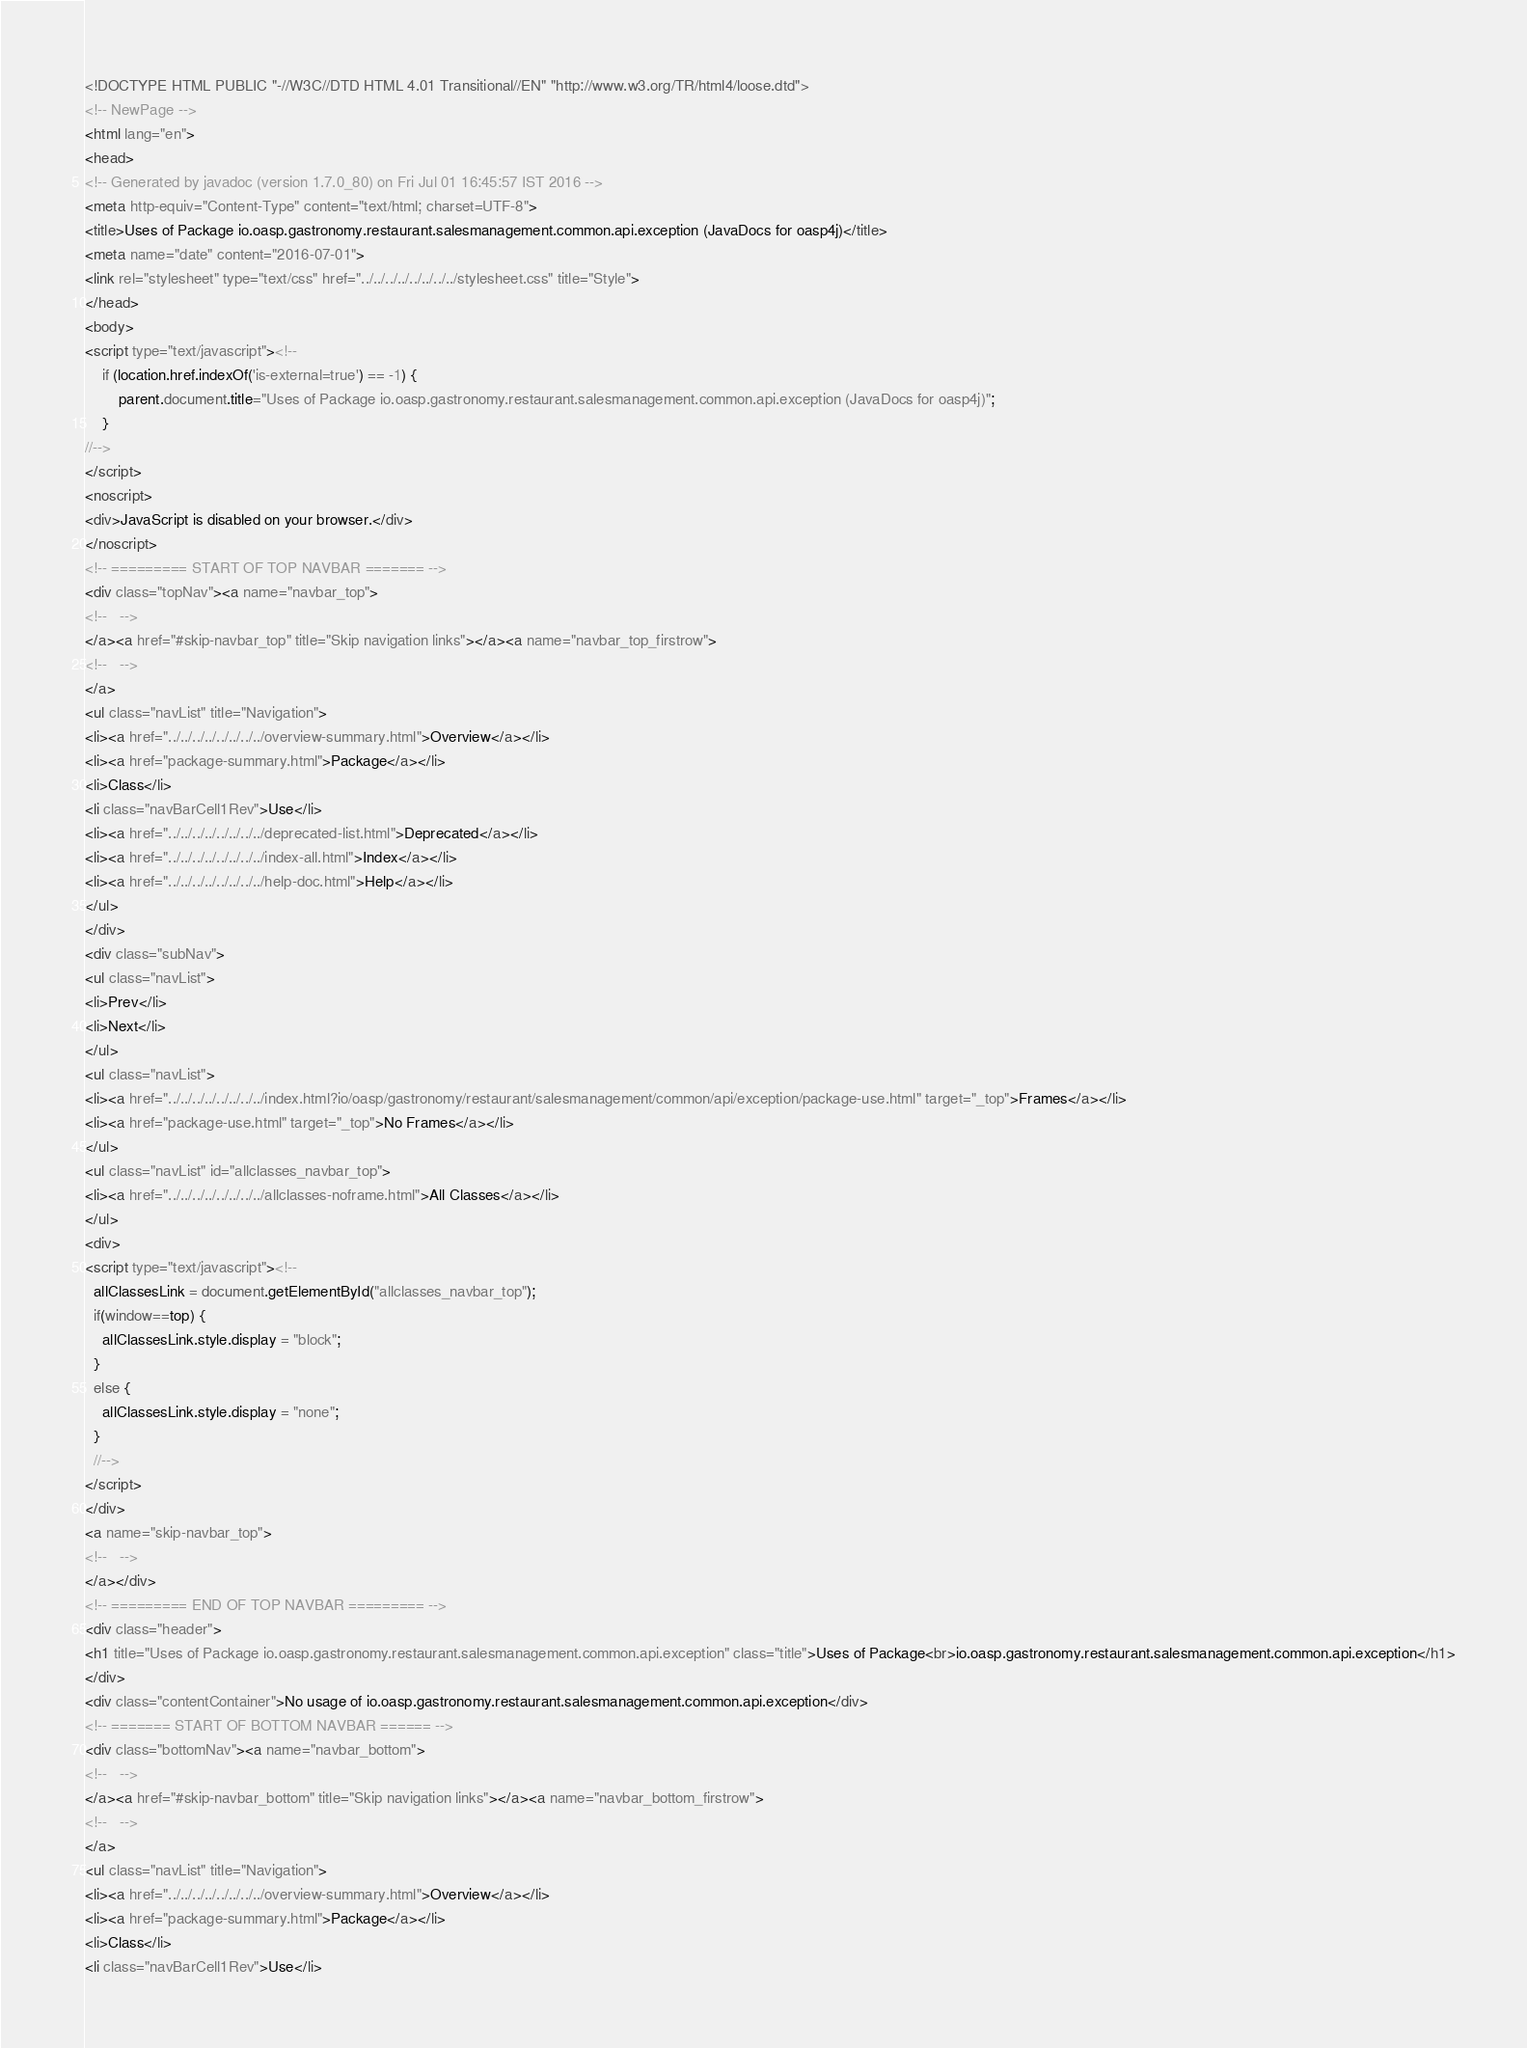Convert code to text. <code><loc_0><loc_0><loc_500><loc_500><_HTML_><!DOCTYPE HTML PUBLIC "-//W3C//DTD HTML 4.01 Transitional//EN" "http://www.w3.org/TR/html4/loose.dtd">
<!-- NewPage -->
<html lang="en">
<head>
<!-- Generated by javadoc (version 1.7.0_80) on Fri Jul 01 16:45:57 IST 2016 -->
<meta http-equiv="Content-Type" content="text/html; charset=UTF-8">
<title>Uses of Package io.oasp.gastronomy.restaurant.salesmanagement.common.api.exception (JavaDocs for oasp4j)</title>
<meta name="date" content="2016-07-01">
<link rel="stylesheet" type="text/css" href="../../../../../../../../stylesheet.css" title="Style">
</head>
<body>
<script type="text/javascript"><!--
    if (location.href.indexOf('is-external=true') == -1) {
        parent.document.title="Uses of Package io.oasp.gastronomy.restaurant.salesmanagement.common.api.exception (JavaDocs for oasp4j)";
    }
//-->
</script>
<noscript>
<div>JavaScript is disabled on your browser.</div>
</noscript>
<!-- ========= START OF TOP NAVBAR ======= -->
<div class="topNav"><a name="navbar_top">
<!--   -->
</a><a href="#skip-navbar_top" title="Skip navigation links"></a><a name="navbar_top_firstrow">
<!--   -->
</a>
<ul class="navList" title="Navigation">
<li><a href="../../../../../../../../overview-summary.html">Overview</a></li>
<li><a href="package-summary.html">Package</a></li>
<li>Class</li>
<li class="navBarCell1Rev">Use</li>
<li><a href="../../../../../../../../deprecated-list.html">Deprecated</a></li>
<li><a href="../../../../../../../../index-all.html">Index</a></li>
<li><a href="../../../../../../../../help-doc.html">Help</a></li>
</ul>
</div>
<div class="subNav">
<ul class="navList">
<li>Prev</li>
<li>Next</li>
</ul>
<ul class="navList">
<li><a href="../../../../../../../../index.html?io/oasp/gastronomy/restaurant/salesmanagement/common/api/exception/package-use.html" target="_top">Frames</a></li>
<li><a href="package-use.html" target="_top">No Frames</a></li>
</ul>
<ul class="navList" id="allclasses_navbar_top">
<li><a href="../../../../../../../../allclasses-noframe.html">All Classes</a></li>
</ul>
<div>
<script type="text/javascript"><!--
  allClassesLink = document.getElementById("allclasses_navbar_top");
  if(window==top) {
    allClassesLink.style.display = "block";
  }
  else {
    allClassesLink.style.display = "none";
  }
  //-->
</script>
</div>
<a name="skip-navbar_top">
<!--   -->
</a></div>
<!-- ========= END OF TOP NAVBAR ========= -->
<div class="header">
<h1 title="Uses of Package io.oasp.gastronomy.restaurant.salesmanagement.common.api.exception" class="title">Uses of Package<br>io.oasp.gastronomy.restaurant.salesmanagement.common.api.exception</h1>
</div>
<div class="contentContainer">No usage of io.oasp.gastronomy.restaurant.salesmanagement.common.api.exception</div>
<!-- ======= START OF BOTTOM NAVBAR ====== -->
<div class="bottomNav"><a name="navbar_bottom">
<!--   -->
</a><a href="#skip-navbar_bottom" title="Skip navigation links"></a><a name="navbar_bottom_firstrow">
<!--   -->
</a>
<ul class="navList" title="Navigation">
<li><a href="../../../../../../../../overview-summary.html">Overview</a></li>
<li><a href="package-summary.html">Package</a></li>
<li>Class</li>
<li class="navBarCell1Rev">Use</li></code> 